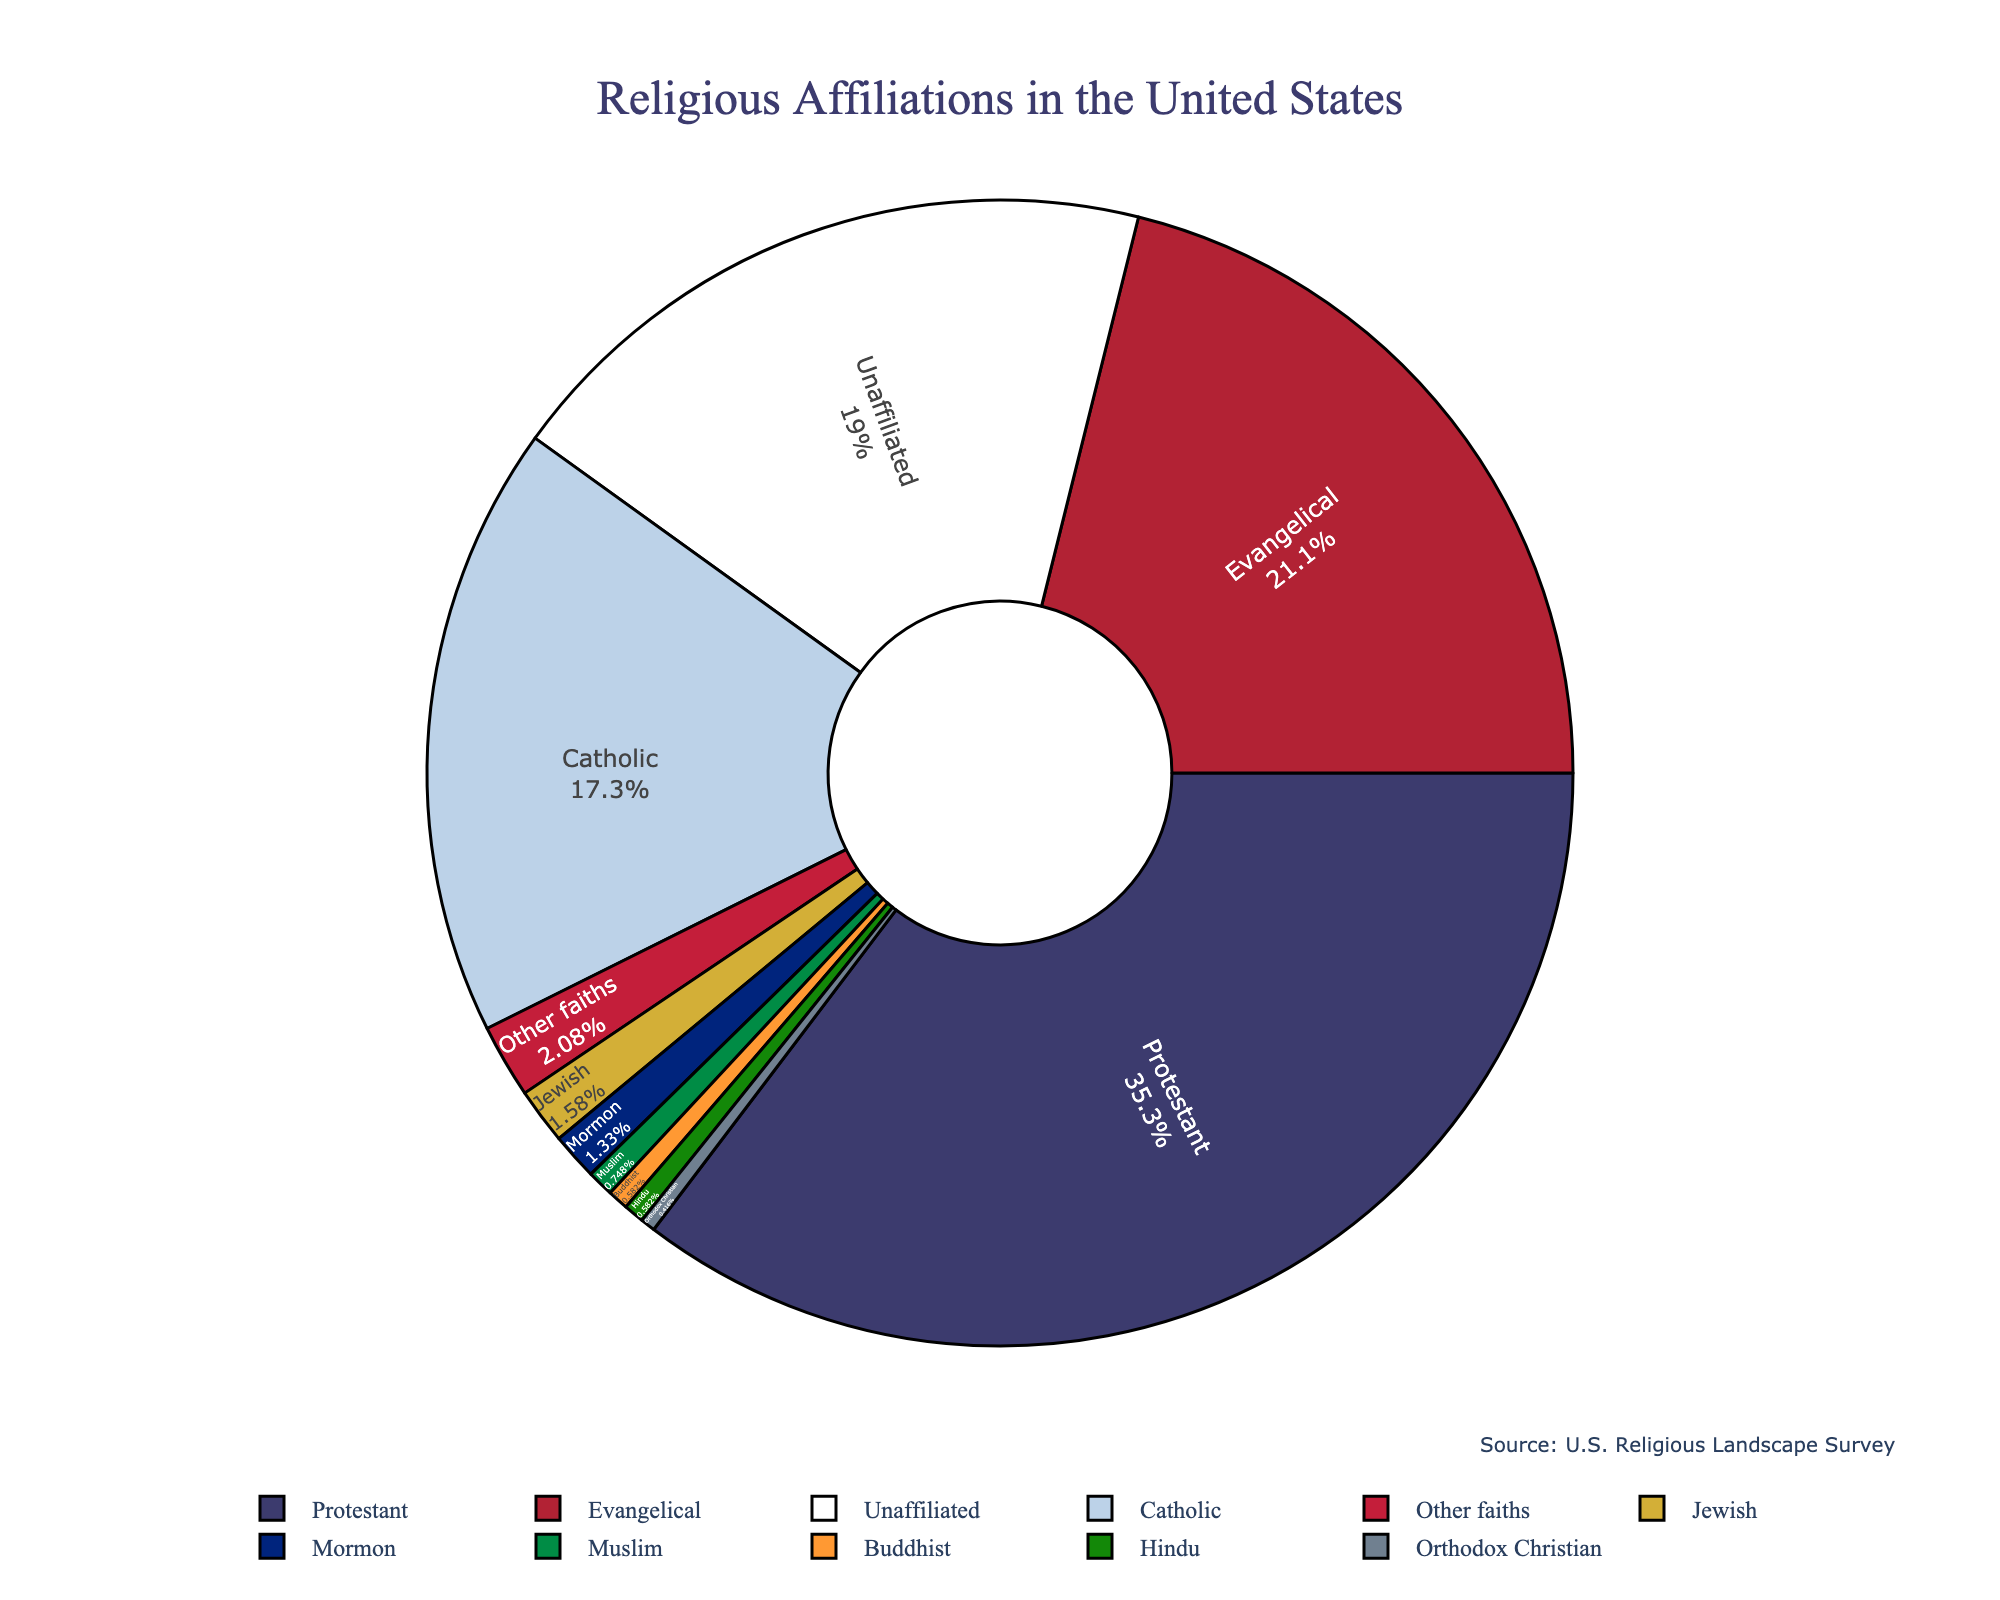Which religious affiliation has the highest percentage of adherents in the United States? The pie chart shows that the Protestant denomination has the largest slice, indicating it has the highest percentage.
Answer: Protestant What's the combined percentage of Catholics and Evangelicals in the United States? The chart indicates that Catholics make up 20.8% and Evangelicals make up 25.4%. Adding these gives 20.8 + 25.4 = 46.2%.
Answer: 46.2% Which denominations have a percentage less than 1%? The chart shows slices for Mormon (1.6%), Orthodox Christian (0.5%), Jewish (1.9%), Muslim (0.9%), Buddhist (0.7%), and Hindu (0.7%), but only Orthodox Christian, Muslim, Buddhist, and Hindu slices are less than 1%.
Answer: Orthodox Christian, Muslim, Buddhist, and Hindu How does the percentage of Unaffiliated compare to that of Protestant? The slice for Unaffiliated is noticeably smaller than that for Protestant. The chart shows Unaffiliated at 22.8% and Protestant at 42.5%. Therefore, Protestants have a higher percentage.
Answer: Protestant has a higher percentage What's the total percentage of non-Christian religions (Jewish, Muslim, Buddhist, Hindu, and other faiths) in the United States? From the chart, Jewish (1.9%), Muslim (0.9%), Buddhist (0.7%), Hindu (0.7%), and Other Faiths (2.5%). Adding these gives 1.9 + 0.9 + 0.7 + 0.7 + 2.5 = 6.7%.
Answer: 6.7% What is the difference in percentage between the Protestant and Catholic denominations? The percentage of Protestants is 42.5% and that of Catholics is 20.8%. The difference is 42.5 - 20.8 = 21.7%.
Answer: 21.7% Which religious affiliation is represented by the third largest slice? The largest slices correspond to Protestant, Evangelical, and Catholic respectively. The third largest is Catholic at 20.8%.
Answer: Catholic Is the percentage of the Unaffiliated higher than that of Evangelical Christians? The chart clearly shows the Unaffiliated at 22.8% and Evangelical Christians at 25.4%. Therefore, Evangelical Christians have a higher percentage.
Answer: Evangelical Christians have a higher percentage What is the color of the segment representing Jewish beliefs, and what percentage does it represent? The segment representing Jewish beliefs is colored green and it forms 1.9% of the chart.
Answer: Green, 1.9% 